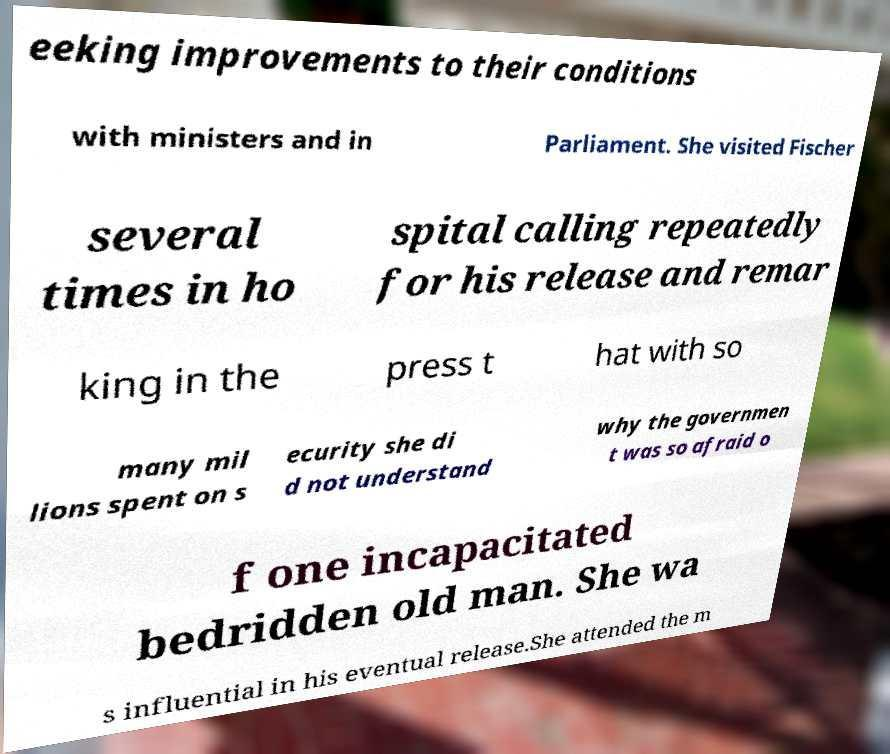Could you extract and type out the text from this image? eeking improvements to their conditions with ministers and in Parliament. She visited Fischer several times in ho spital calling repeatedly for his release and remar king in the press t hat with so many mil lions spent on s ecurity she di d not understand why the governmen t was so afraid o f one incapacitated bedridden old man. She wa s influential in his eventual release.She attended the m 